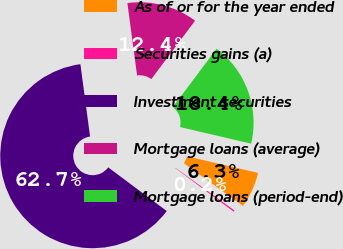Convert chart to OTSL. <chart><loc_0><loc_0><loc_500><loc_500><pie_chart><fcel>As of or for the year ended<fcel>Securities gains (a)<fcel>Investment securities<fcel>Mortgage loans (average)<fcel>Mortgage loans (period-end)<nl><fcel>6.3%<fcel>0.24%<fcel>62.68%<fcel>12.36%<fcel>18.42%<nl></chart> 